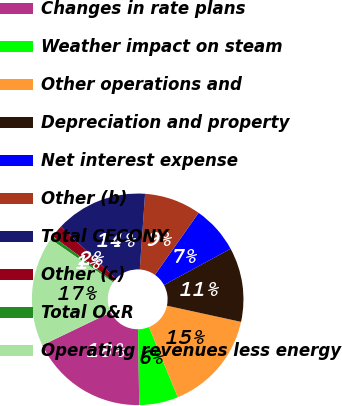<chart> <loc_0><loc_0><loc_500><loc_500><pie_chart><fcel>Changes in rate plans<fcel>Weather impact on steam<fcel>Other operations and<fcel>Depreciation and property<fcel>Net interest expense<fcel>Other (b)<fcel>Total CECONY<fcel>Other (c)<fcel>Total O&R<fcel>Operating revenues less energy<nl><fcel>18.09%<fcel>5.96%<fcel>15.39%<fcel>11.35%<fcel>7.3%<fcel>8.65%<fcel>14.04%<fcel>1.91%<fcel>0.56%<fcel>16.74%<nl></chart> 